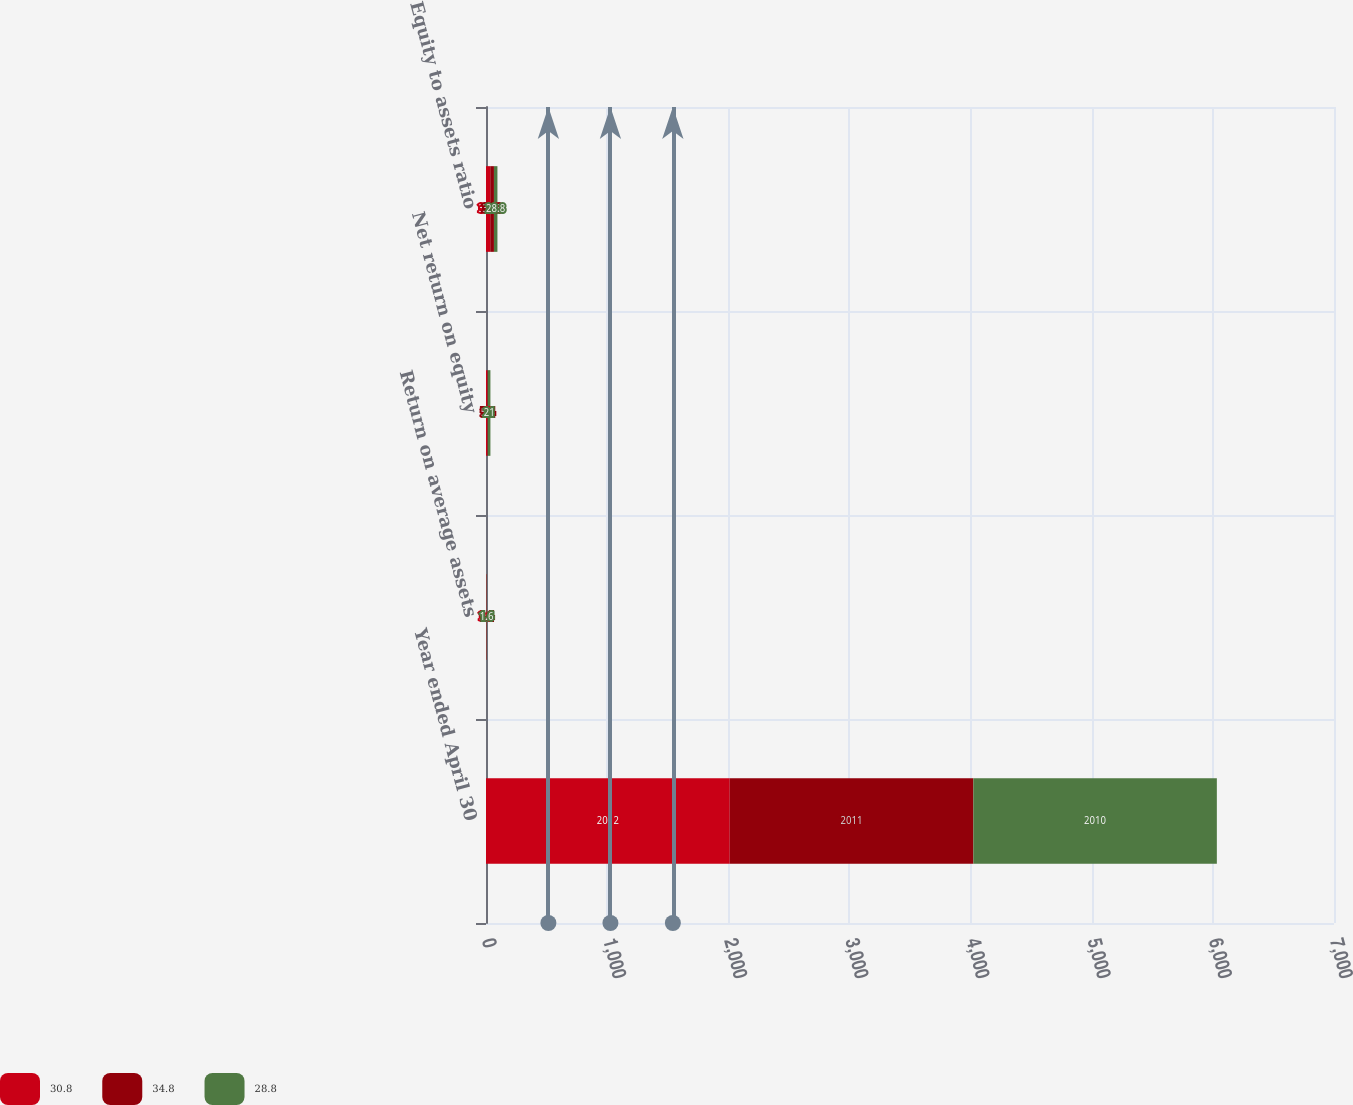<chart> <loc_0><loc_0><loc_500><loc_500><stacked_bar_chart><ecel><fcel>Year ended April 30<fcel>Return on average assets<fcel>Net return on equity<fcel>Equity to assets ratio<nl><fcel>30.8<fcel>2012<fcel>3.1<fcel>10<fcel>34.8<nl><fcel>34.8<fcel>2011<fcel>1.4<fcel>5.4<fcel>30.8<nl><fcel>28.8<fcel>2010<fcel>1.6<fcel>21<fcel>28.8<nl></chart> 